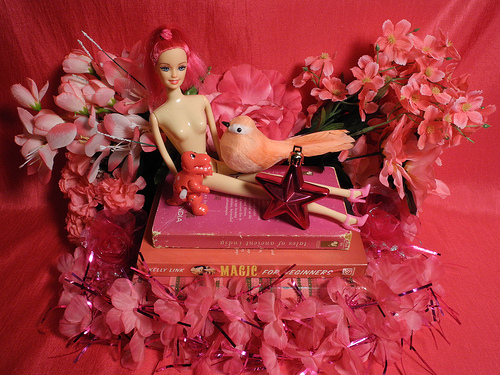<image>
Is there a star in front of the barbie? Yes. The star is positioned in front of the barbie, appearing closer to the camera viewpoint. 